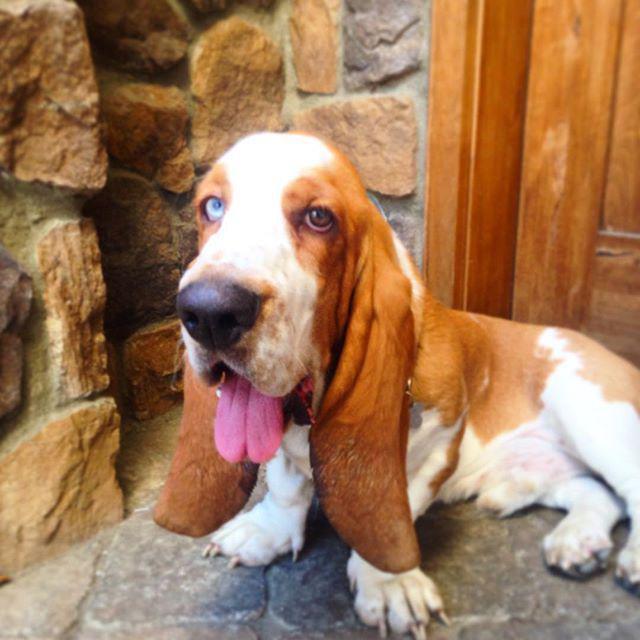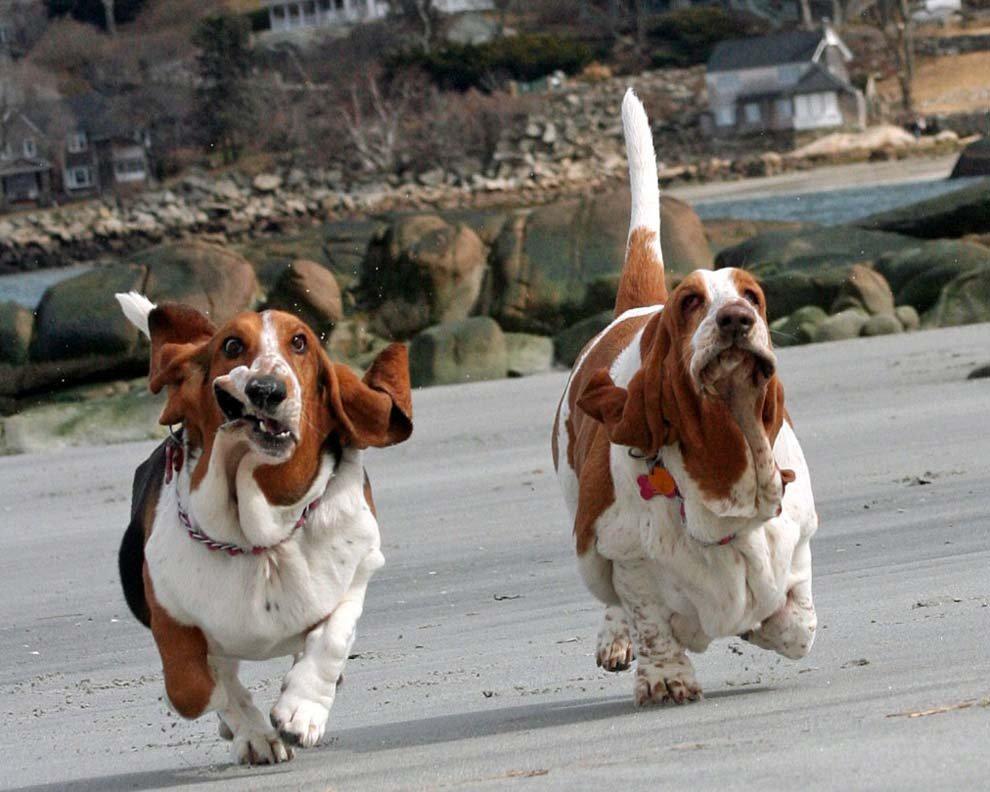The first image is the image on the left, the second image is the image on the right. Evaluate the accuracy of this statement regarding the images: "There is one hound in the left image and two hounds in the right image.". Is it true? Answer yes or no. Yes. The first image is the image on the left, the second image is the image on the right. For the images shown, is this caption "There are three dogs that are not running." true? Answer yes or no. No. 